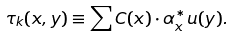<formula> <loc_0><loc_0><loc_500><loc_500>\tau _ { k } ( x , y ) \equiv \sum C ( x ) \cdot \alpha _ { x } ^ { * } { u } ( y ) .</formula> 